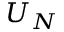<formula> <loc_0><loc_0><loc_500><loc_500>U _ { N }</formula> 